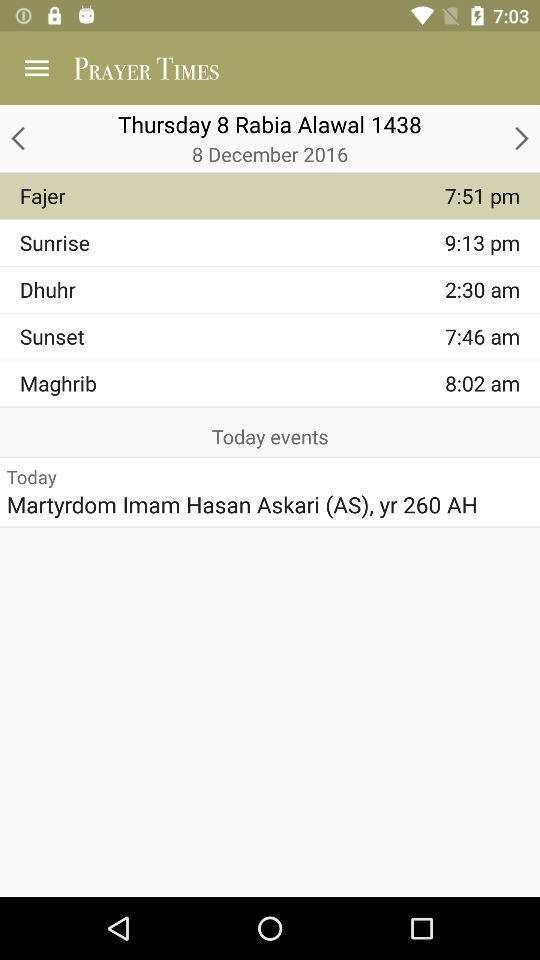What is the date today? The date is December 8, 2016. 